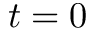Convert formula to latex. <formula><loc_0><loc_0><loc_500><loc_500>t = 0</formula> 